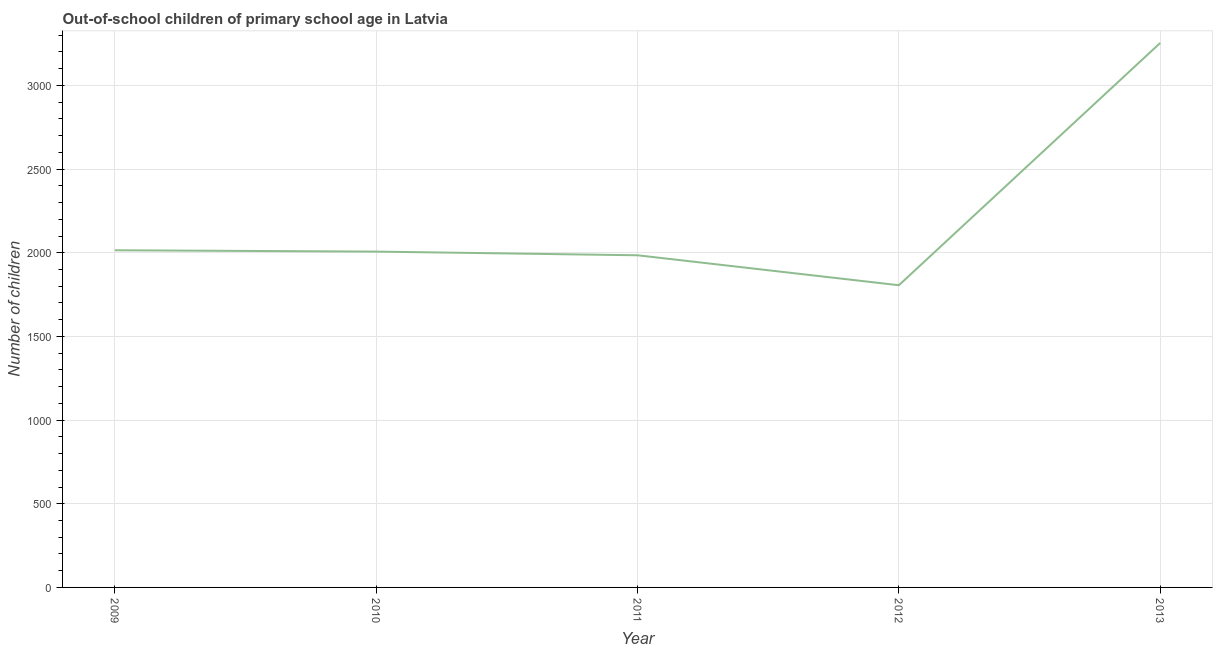What is the number of out-of-school children in 2012?
Offer a terse response. 1806. Across all years, what is the maximum number of out-of-school children?
Provide a succinct answer. 3254. Across all years, what is the minimum number of out-of-school children?
Make the answer very short. 1806. In which year was the number of out-of-school children maximum?
Offer a very short reply. 2013. What is the sum of the number of out-of-school children?
Your response must be concise. 1.11e+04. What is the difference between the number of out-of-school children in 2010 and 2012?
Make the answer very short. 201. What is the average number of out-of-school children per year?
Ensure brevity in your answer.  2213.4. What is the median number of out-of-school children?
Make the answer very short. 2007. Do a majority of the years between 2010 and 2011 (inclusive) have number of out-of-school children greater than 1800 ?
Your answer should be compact. Yes. What is the ratio of the number of out-of-school children in 2009 to that in 2013?
Your answer should be compact. 0.62. What is the difference between the highest and the second highest number of out-of-school children?
Your response must be concise. 1239. Is the sum of the number of out-of-school children in 2009 and 2013 greater than the maximum number of out-of-school children across all years?
Provide a succinct answer. Yes. What is the difference between the highest and the lowest number of out-of-school children?
Ensure brevity in your answer.  1448. In how many years, is the number of out-of-school children greater than the average number of out-of-school children taken over all years?
Your answer should be compact. 1. How many lines are there?
Keep it short and to the point. 1. How many years are there in the graph?
Your answer should be compact. 5. What is the difference between two consecutive major ticks on the Y-axis?
Your answer should be very brief. 500. Does the graph contain any zero values?
Your response must be concise. No. Does the graph contain grids?
Your answer should be compact. Yes. What is the title of the graph?
Your answer should be compact. Out-of-school children of primary school age in Latvia. What is the label or title of the Y-axis?
Offer a terse response. Number of children. What is the Number of children in 2009?
Offer a terse response. 2015. What is the Number of children of 2010?
Give a very brief answer. 2007. What is the Number of children of 2011?
Provide a succinct answer. 1985. What is the Number of children of 2012?
Offer a very short reply. 1806. What is the Number of children of 2013?
Keep it short and to the point. 3254. What is the difference between the Number of children in 2009 and 2011?
Offer a terse response. 30. What is the difference between the Number of children in 2009 and 2012?
Your answer should be very brief. 209. What is the difference between the Number of children in 2009 and 2013?
Your response must be concise. -1239. What is the difference between the Number of children in 2010 and 2011?
Keep it short and to the point. 22. What is the difference between the Number of children in 2010 and 2012?
Make the answer very short. 201. What is the difference between the Number of children in 2010 and 2013?
Make the answer very short. -1247. What is the difference between the Number of children in 2011 and 2012?
Offer a very short reply. 179. What is the difference between the Number of children in 2011 and 2013?
Keep it short and to the point. -1269. What is the difference between the Number of children in 2012 and 2013?
Provide a short and direct response. -1448. What is the ratio of the Number of children in 2009 to that in 2010?
Offer a very short reply. 1. What is the ratio of the Number of children in 2009 to that in 2011?
Provide a succinct answer. 1.01. What is the ratio of the Number of children in 2009 to that in 2012?
Give a very brief answer. 1.12. What is the ratio of the Number of children in 2009 to that in 2013?
Provide a short and direct response. 0.62. What is the ratio of the Number of children in 2010 to that in 2012?
Your answer should be very brief. 1.11. What is the ratio of the Number of children in 2010 to that in 2013?
Ensure brevity in your answer.  0.62. What is the ratio of the Number of children in 2011 to that in 2012?
Your answer should be very brief. 1.1. What is the ratio of the Number of children in 2011 to that in 2013?
Provide a succinct answer. 0.61. What is the ratio of the Number of children in 2012 to that in 2013?
Your response must be concise. 0.56. 